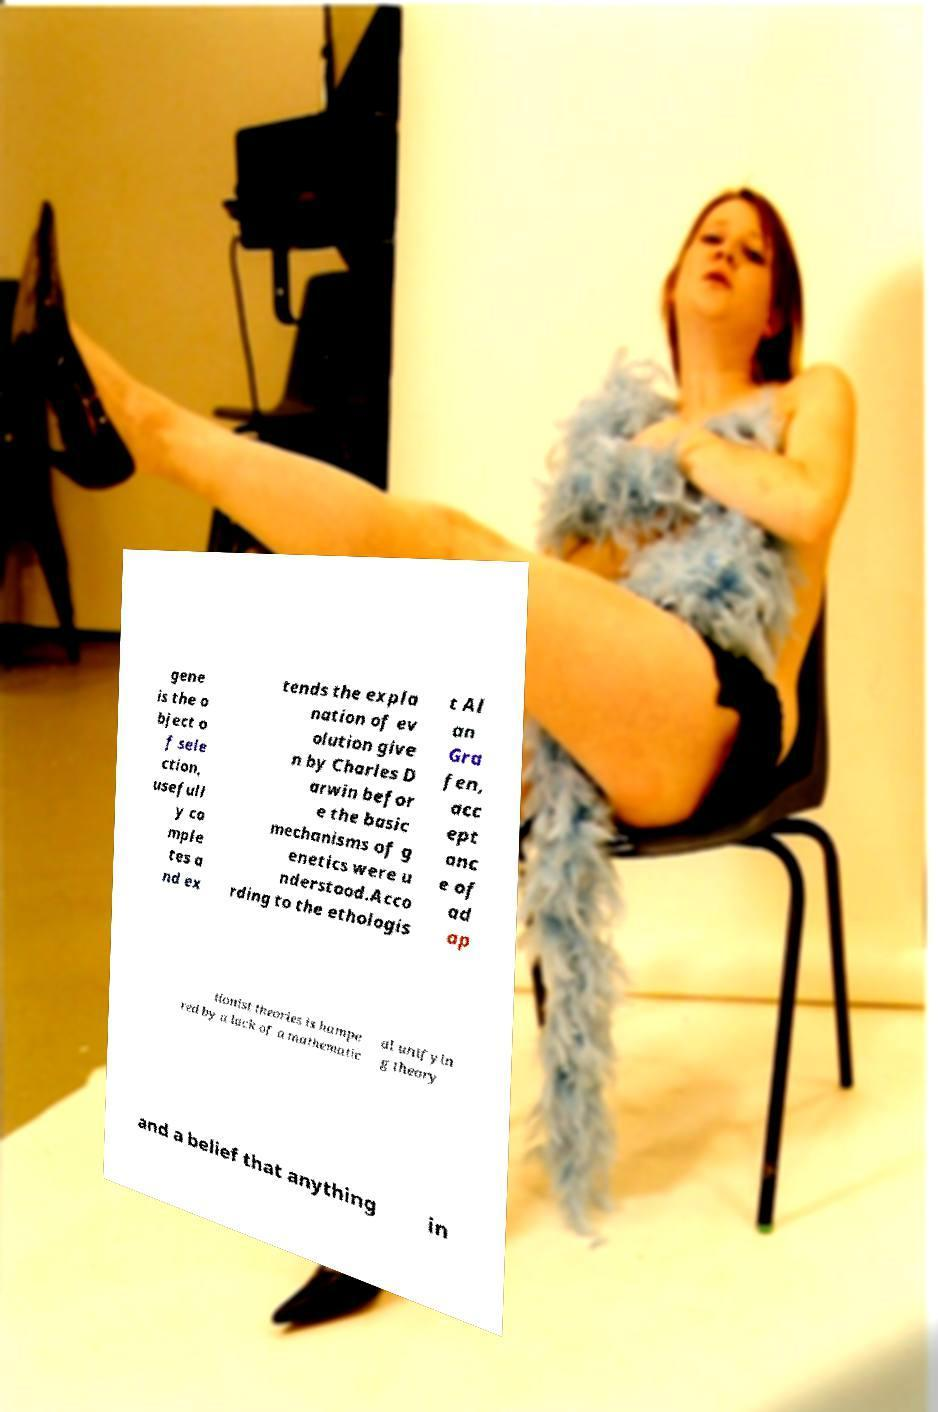Can you read and provide the text displayed in the image?This photo seems to have some interesting text. Can you extract and type it out for me? gene is the o bject o f sele ction, usefull y co mple tes a nd ex tends the expla nation of ev olution give n by Charles D arwin befor e the basic mechanisms of g enetics were u nderstood.Acco rding to the ethologis t Al an Gra fen, acc ept anc e of ad ap tionist theories is hampe red by a lack of a mathematic al unifyin g theory and a belief that anything in 